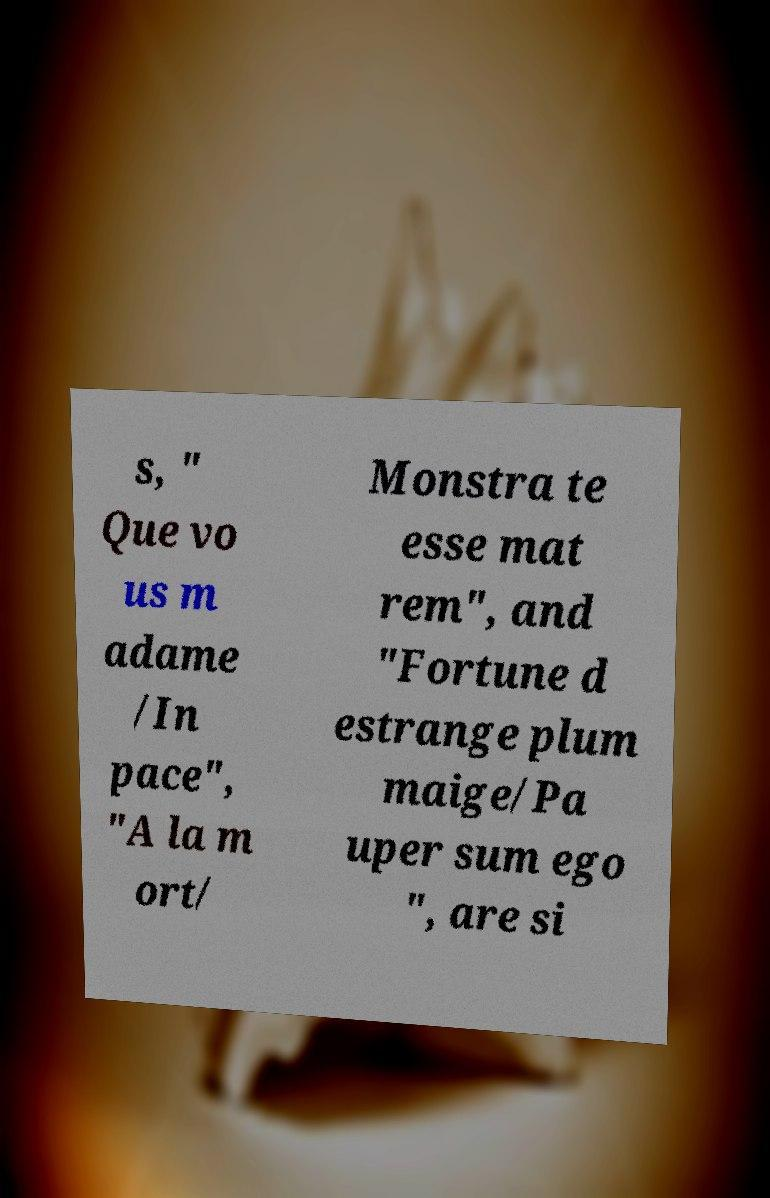Can you accurately transcribe the text from the provided image for me? s, " Que vo us m adame /In pace", "A la m ort/ Monstra te esse mat rem", and "Fortune d estrange plum maige/Pa uper sum ego ", are si 